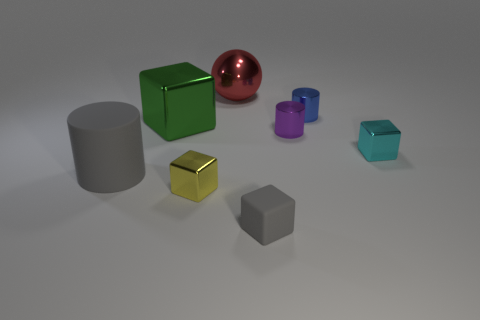What color is the tiny thing that is both on the right side of the tiny gray cube and on the left side of the blue thing?
Provide a short and direct response. Purple. What color is the large metal ball?
Your response must be concise. Red. There is a cylinder that is the same color as the tiny rubber cube; what material is it?
Your response must be concise. Rubber. Are there any gray things that have the same shape as the tiny purple object?
Offer a very short reply. Yes. How big is the metal cylinder that is in front of the blue metallic cylinder?
Offer a terse response. Small. There is a green block that is the same size as the red metallic thing; what is its material?
Give a very brief answer. Metal. Are there more blue metal balls than small gray matte cubes?
Provide a short and direct response. No. There is a gray matte cube in front of the metallic block behind the tiny cyan thing; how big is it?
Provide a short and direct response. Small. What shape is the purple thing that is the same size as the yellow block?
Provide a short and direct response. Cylinder. There is a big object that is to the left of the block that is behind the metal block on the right side of the tiny blue metal cylinder; what is its shape?
Provide a short and direct response. Cylinder. 